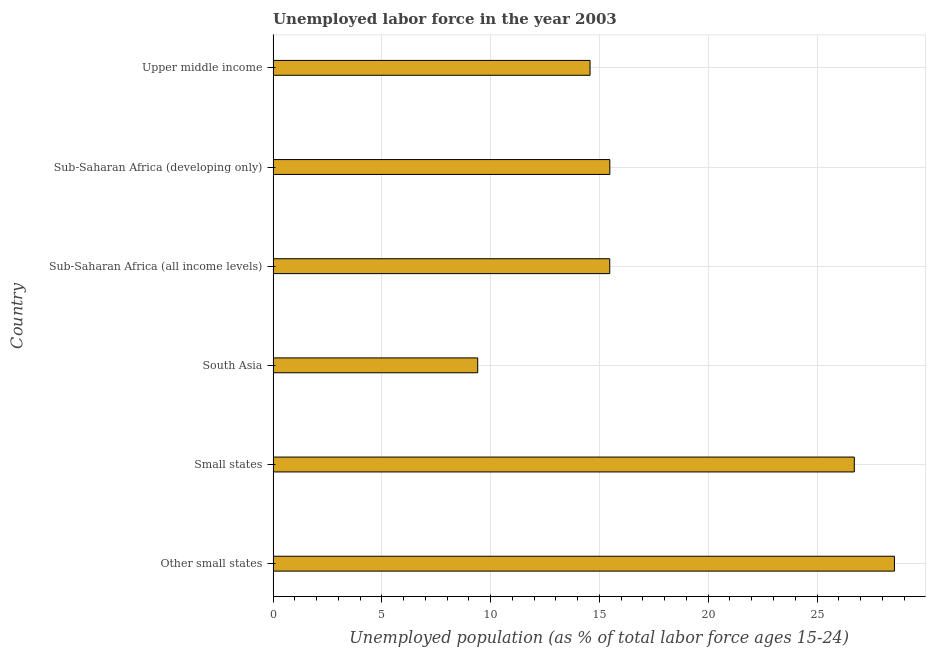What is the title of the graph?
Your response must be concise. Unemployed labor force in the year 2003. What is the label or title of the X-axis?
Offer a very short reply. Unemployed population (as % of total labor force ages 15-24). What is the label or title of the Y-axis?
Make the answer very short. Country. What is the total unemployed youth population in Other small states?
Make the answer very short. 28.56. Across all countries, what is the maximum total unemployed youth population?
Provide a short and direct response. 28.56. Across all countries, what is the minimum total unemployed youth population?
Keep it short and to the point. 9.4. In which country was the total unemployed youth population maximum?
Your answer should be compact. Other small states. What is the sum of the total unemployed youth population?
Your answer should be very brief. 110.2. What is the difference between the total unemployed youth population in Sub-Saharan Africa (all income levels) and Sub-Saharan Africa (developing only)?
Your response must be concise. -0. What is the average total unemployed youth population per country?
Offer a very short reply. 18.37. What is the median total unemployed youth population?
Make the answer very short. 15.48. What is the ratio of the total unemployed youth population in South Asia to that in Sub-Saharan Africa (all income levels)?
Your response must be concise. 0.61. What is the difference between the highest and the second highest total unemployed youth population?
Your answer should be compact. 1.84. Is the sum of the total unemployed youth population in Sub-Saharan Africa (all income levels) and Sub-Saharan Africa (developing only) greater than the maximum total unemployed youth population across all countries?
Your answer should be very brief. Yes. What is the difference between the highest and the lowest total unemployed youth population?
Provide a short and direct response. 19.16. How many bars are there?
Offer a terse response. 6. Are all the bars in the graph horizontal?
Your answer should be compact. Yes. How many countries are there in the graph?
Keep it short and to the point. 6. What is the difference between two consecutive major ticks on the X-axis?
Make the answer very short. 5. What is the Unemployed population (as % of total labor force ages 15-24) of Other small states?
Your answer should be very brief. 28.56. What is the Unemployed population (as % of total labor force ages 15-24) in Small states?
Ensure brevity in your answer.  26.71. What is the Unemployed population (as % of total labor force ages 15-24) of South Asia?
Your response must be concise. 9.4. What is the Unemployed population (as % of total labor force ages 15-24) of Sub-Saharan Africa (all income levels)?
Keep it short and to the point. 15.47. What is the Unemployed population (as % of total labor force ages 15-24) in Sub-Saharan Africa (developing only)?
Your response must be concise. 15.48. What is the Unemployed population (as % of total labor force ages 15-24) in Upper middle income?
Provide a succinct answer. 14.57. What is the difference between the Unemployed population (as % of total labor force ages 15-24) in Other small states and Small states?
Provide a succinct answer. 1.84. What is the difference between the Unemployed population (as % of total labor force ages 15-24) in Other small states and South Asia?
Your answer should be compact. 19.16. What is the difference between the Unemployed population (as % of total labor force ages 15-24) in Other small states and Sub-Saharan Africa (all income levels)?
Your answer should be very brief. 13.09. What is the difference between the Unemployed population (as % of total labor force ages 15-24) in Other small states and Sub-Saharan Africa (developing only)?
Make the answer very short. 13.08. What is the difference between the Unemployed population (as % of total labor force ages 15-24) in Other small states and Upper middle income?
Give a very brief answer. 13.99. What is the difference between the Unemployed population (as % of total labor force ages 15-24) in Small states and South Asia?
Offer a very short reply. 17.31. What is the difference between the Unemployed population (as % of total labor force ages 15-24) in Small states and Sub-Saharan Africa (all income levels)?
Ensure brevity in your answer.  11.24. What is the difference between the Unemployed population (as % of total labor force ages 15-24) in Small states and Sub-Saharan Africa (developing only)?
Ensure brevity in your answer.  11.24. What is the difference between the Unemployed population (as % of total labor force ages 15-24) in Small states and Upper middle income?
Offer a very short reply. 12.15. What is the difference between the Unemployed population (as % of total labor force ages 15-24) in South Asia and Sub-Saharan Africa (all income levels)?
Provide a short and direct response. -6.07. What is the difference between the Unemployed population (as % of total labor force ages 15-24) in South Asia and Sub-Saharan Africa (developing only)?
Your response must be concise. -6.07. What is the difference between the Unemployed population (as % of total labor force ages 15-24) in South Asia and Upper middle income?
Ensure brevity in your answer.  -5.16. What is the difference between the Unemployed population (as % of total labor force ages 15-24) in Sub-Saharan Africa (all income levels) and Sub-Saharan Africa (developing only)?
Offer a very short reply. -0. What is the difference between the Unemployed population (as % of total labor force ages 15-24) in Sub-Saharan Africa (all income levels) and Upper middle income?
Provide a short and direct response. 0.91. What is the difference between the Unemployed population (as % of total labor force ages 15-24) in Sub-Saharan Africa (developing only) and Upper middle income?
Your response must be concise. 0.91. What is the ratio of the Unemployed population (as % of total labor force ages 15-24) in Other small states to that in Small states?
Your answer should be compact. 1.07. What is the ratio of the Unemployed population (as % of total labor force ages 15-24) in Other small states to that in South Asia?
Your answer should be compact. 3.04. What is the ratio of the Unemployed population (as % of total labor force ages 15-24) in Other small states to that in Sub-Saharan Africa (all income levels)?
Your answer should be compact. 1.85. What is the ratio of the Unemployed population (as % of total labor force ages 15-24) in Other small states to that in Sub-Saharan Africa (developing only)?
Your answer should be compact. 1.84. What is the ratio of the Unemployed population (as % of total labor force ages 15-24) in Other small states to that in Upper middle income?
Ensure brevity in your answer.  1.96. What is the ratio of the Unemployed population (as % of total labor force ages 15-24) in Small states to that in South Asia?
Ensure brevity in your answer.  2.84. What is the ratio of the Unemployed population (as % of total labor force ages 15-24) in Small states to that in Sub-Saharan Africa (all income levels)?
Ensure brevity in your answer.  1.73. What is the ratio of the Unemployed population (as % of total labor force ages 15-24) in Small states to that in Sub-Saharan Africa (developing only)?
Offer a very short reply. 1.73. What is the ratio of the Unemployed population (as % of total labor force ages 15-24) in Small states to that in Upper middle income?
Your response must be concise. 1.83. What is the ratio of the Unemployed population (as % of total labor force ages 15-24) in South Asia to that in Sub-Saharan Africa (all income levels)?
Ensure brevity in your answer.  0.61. What is the ratio of the Unemployed population (as % of total labor force ages 15-24) in South Asia to that in Sub-Saharan Africa (developing only)?
Provide a succinct answer. 0.61. What is the ratio of the Unemployed population (as % of total labor force ages 15-24) in South Asia to that in Upper middle income?
Your response must be concise. 0.65. What is the ratio of the Unemployed population (as % of total labor force ages 15-24) in Sub-Saharan Africa (all income levels) to that in Upper middle income?
Offer a terse response. 1.06. What is the ratio of the Unemployed population (as % of total labor force ages 15-24) in Sub-Saharan Africa (developing only) to that in Upper middle income?
Your response must be concise. 1.06. 